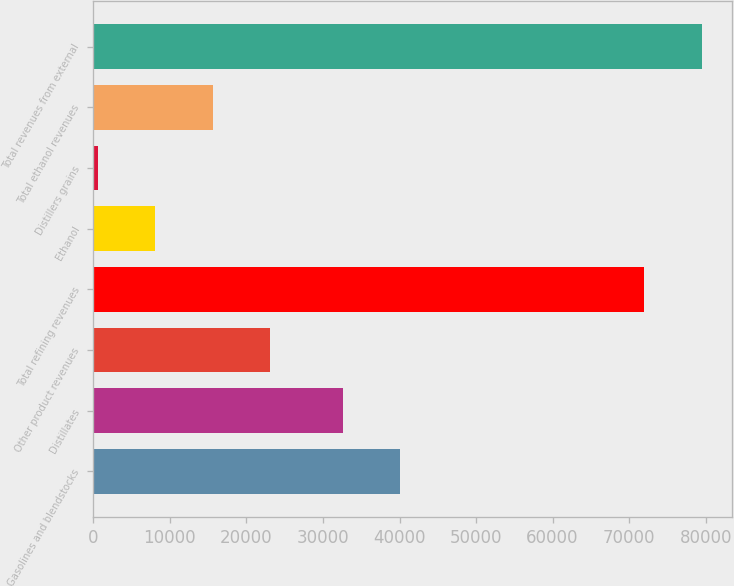<chart> <loc_0><loc_0><loc_500><loc_500><bar_chart><fcel>Gasolines and blendstocks<fcel>Distillates<fcel>Other product revenues<fcel>Total refining revenues<fcel>Ethanol<fcel>Distillers grains<fcel>Total ethanol revenues<fcel>Total revenues from external<nl><fcel>40083.3<fcel>32576<fcel>23107.9<fcel>71968<fcel>8093.3<fcel>586<fcel>15600.6<fcel>79475.3<nl></chart> 